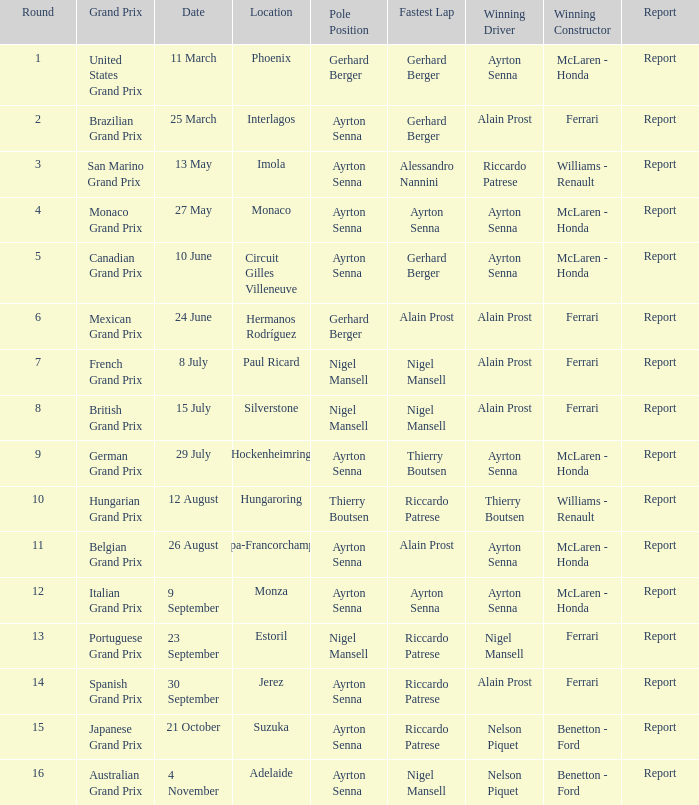What is the foremost spot for the german grand prix? Ayrton Senna. 